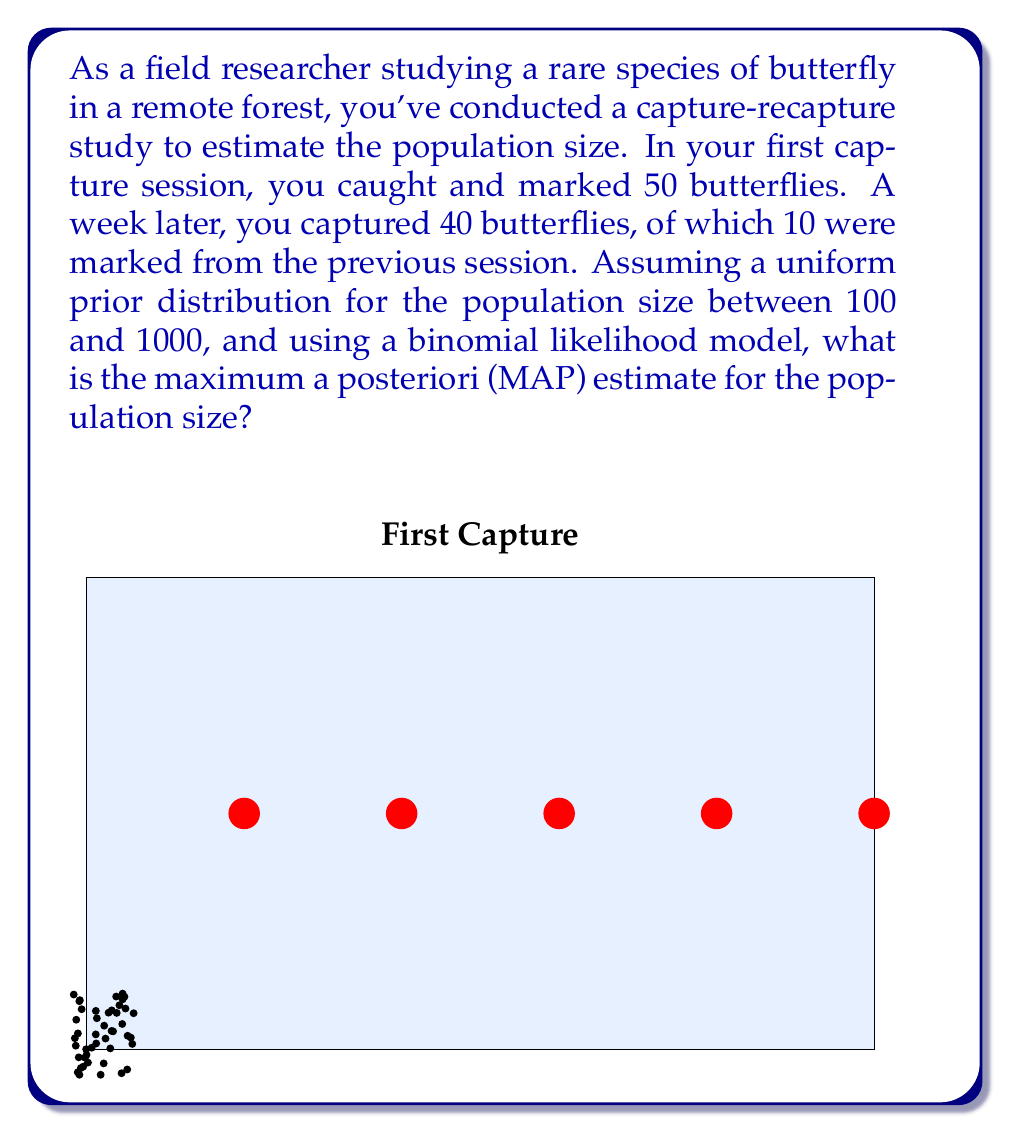Can you answer this question? To solve this problem, we'll use Bayesian inference with a uniform prior and a binomial likelihood model. Let's break it down step by step:

1) Let $N$ be the population size we're estimating.

2) Prior distribution: Uniform over [100, 1000]
   $p(N) = \frac{1}{900}$ for $100 \leq N \leq 1000$

3) Likelihood function: Binomial model
   $p(data|N) = \binom{40}{10} (\frac{50}{N})^{10} (1-\frac{50}{N})^{30}$

4) Posterior distribution:
   $p(N|data) \propto p(data|N) \cdot p(N)$

5) The MAP estimate is the value of $N$ that maximizes the posterior probability. Since the prior is uniform, this is equivalent to maximizing the likelihood function.

6) Taking the log of the likelihood function (ignoring constant terms):
   $\log L(N) = 10 \log(\frac{50}{N}) + 30 \log(1-\frac{50}{N})$

7) To find the maximum, we differentiate and set to zero:
   $\frac{d}{dN} \log L(N) = -\frac{10}{N} + \frac{1500}{N(N-50)} = 0$

8) Solving this equation:
   $-10(N-50) + 1500 = 0$
   $-10N + 500 + 1500 = 0$
   $-10N + 2000 = 0$
   $N = 200$

9) We need to verify that this critical point is indeed a maximum and falls within our prior range, which it does.

Therefore, the MAP estimate for the population size is 200 butterflies.
Answer: 200 butterflies 